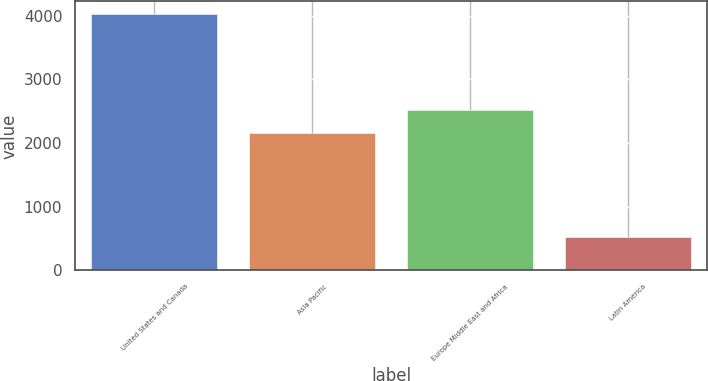Convert chart to OTSL. <chart><loc_0><loc_0><loc_500><loc_500><bar_chart><fcel>United States and Canada<fcel>Asia Pacific<fcel>Europe Middle East and Africa<fcel>Latin America<nl><fcel>4025<fcel>2163<fcel>2514<fcel>515<nl></chart> 